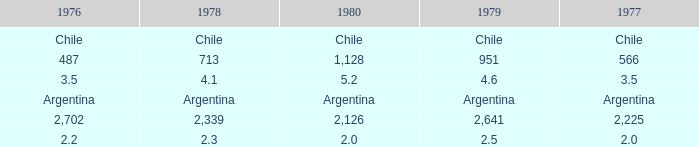What is 1976 when 1980 is 2.0? 2.2. 